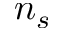Convert formula to latex. <formula><loc_0><loc_0><loc_500><loc_500>n _ { s }</formula> 